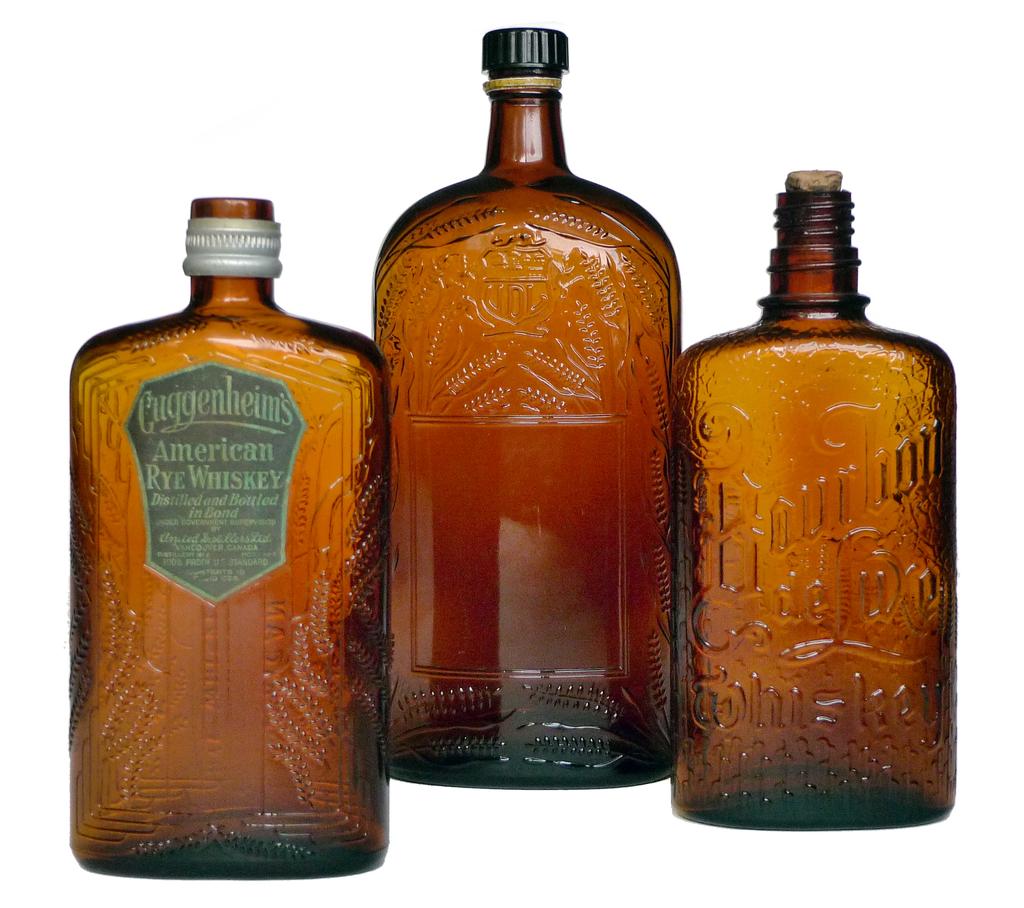Is this american rye whisky?
Offer a very short reply. Yes. 